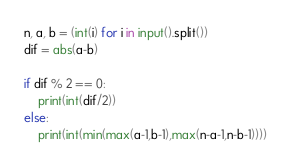<code> <loc_0><loc_0><loc_500><loc_500><_Python_>n, a, b = (int(i) for i in input().split()) 
dif = abs(a-b)

if dif % 2 == 0:
    print(int(dif/2))
else:
    print(int(min(max(a-1,b-1),max(n-a-1,n-b-1))))</code> 